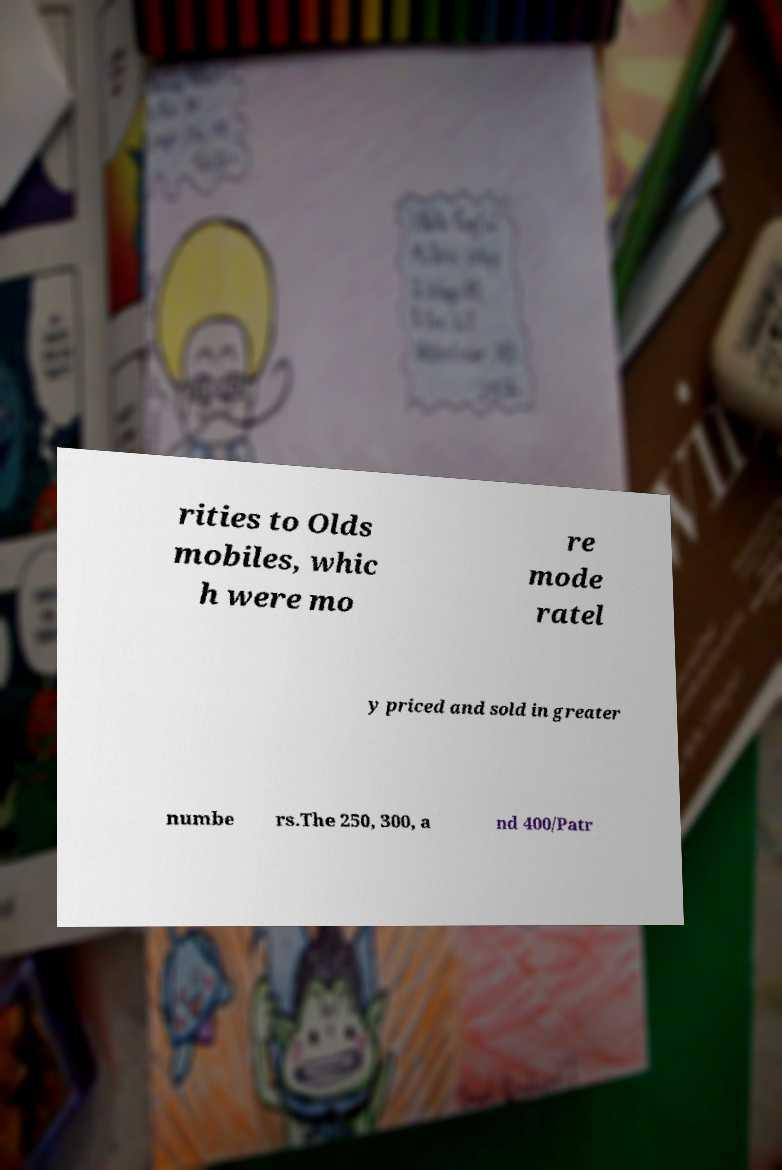Could you extract and type out the text from this image? rities to Olds mobiles, whic h were mo re mode ratel y priced and sold in greater numbe rs.The 250, 300, a nd 400/Patr 